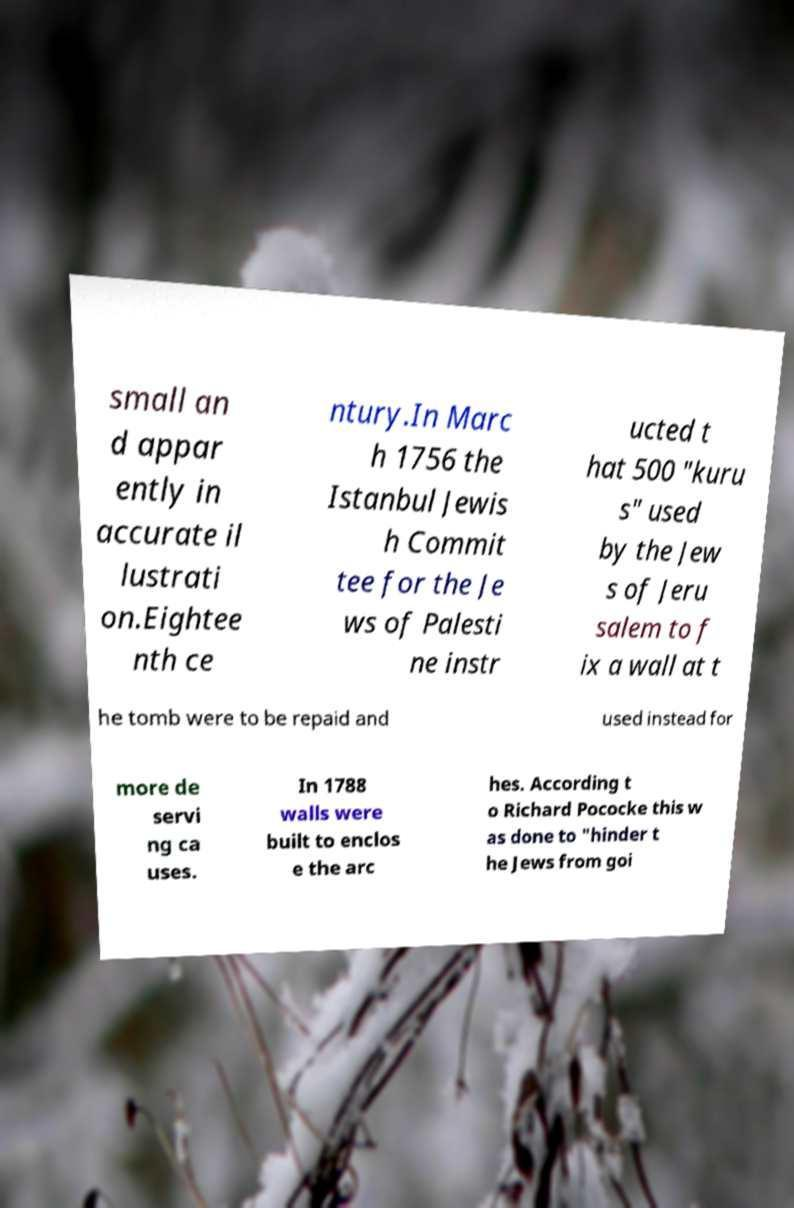Please read and relay the text visible in this image. What does it say? small an d appar ently in accurate il lustrati on.Eightee nth ce ntury.In Marc h 1756 the Istanbul Jewis h Commit tee for the Je ws of Palesti ne instr ucted t hat 500 "kuru s" used by the Jew s of Jeru salem to f ix a wall at t he tomb were to be repaid and used instead for more de servi ng ca uses. In 1788 walls were built to enclos e the arc hes. According t o Richard Pococke this w as done to "hinder t he Jews from goi 